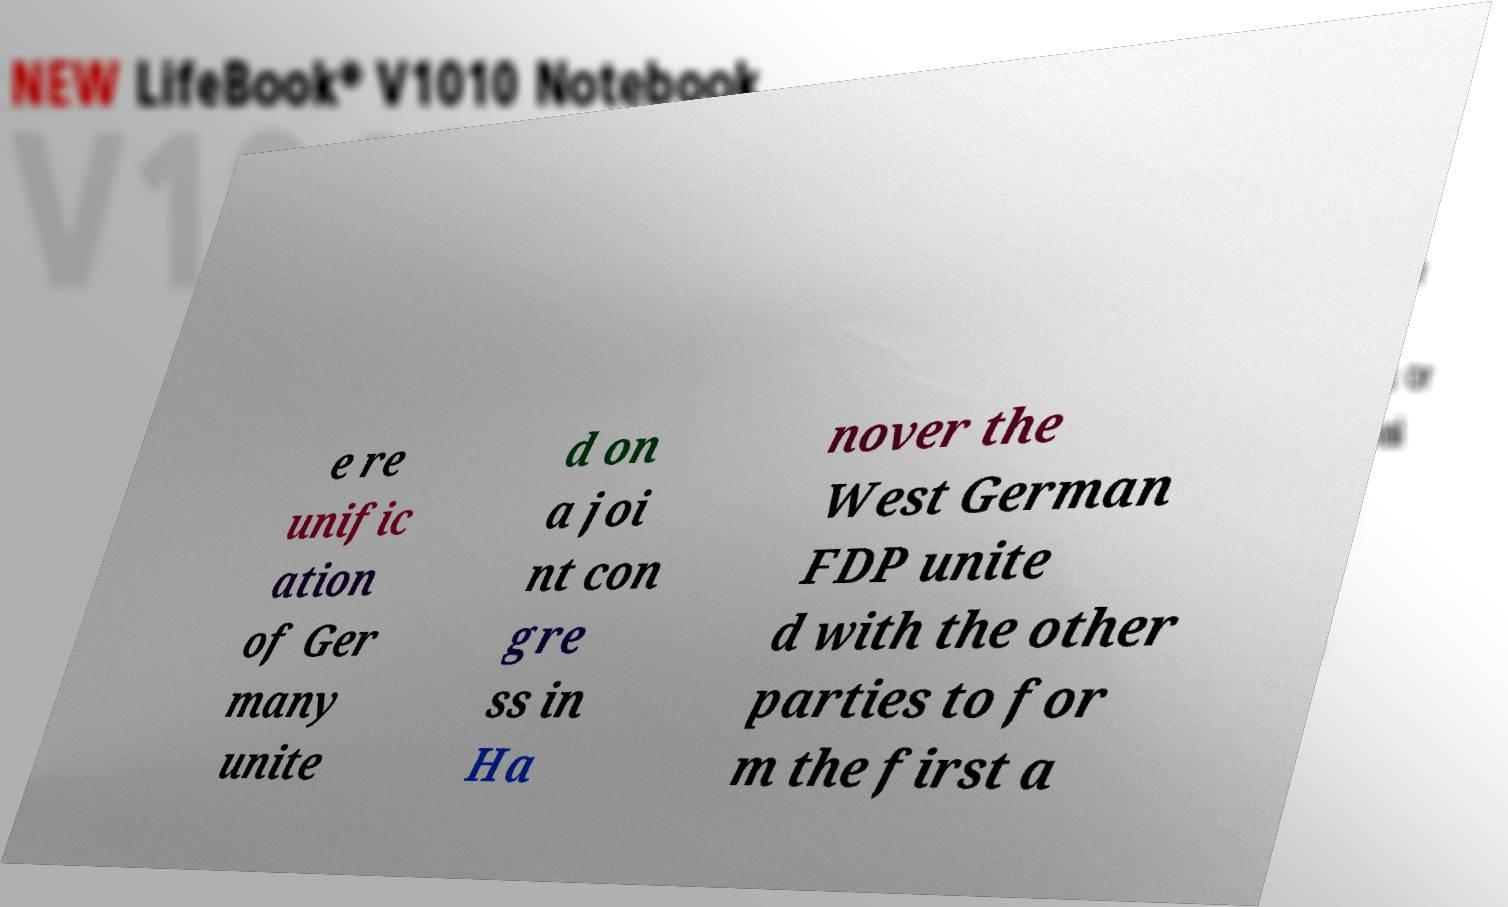Please read and relay the text visible in this image. What does it say? e re unific ation of Ger many unite d on a joi nt con gre ss in Ha nover the West German FDP unite d with the other parties to for m the first a 